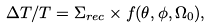<formula> <loc_0><loc_0><loc_500><loc_500>\Delta T / T = \Sigma _ { r e c } \times f ( \theta , \phi , \Omega _ { 0 } ) ,</formula> 